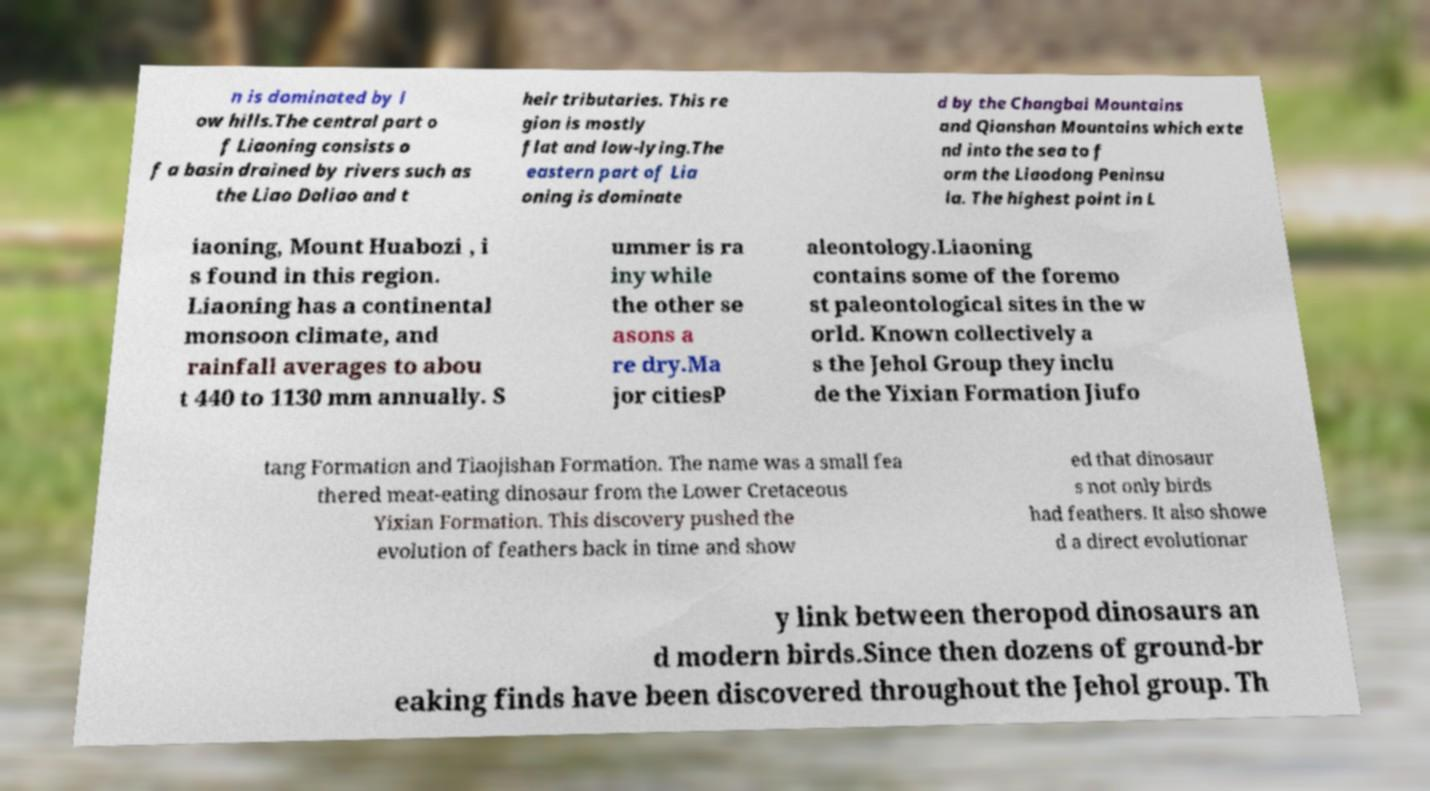Please read and relay the text visible in this image. What does it say? n is dominated by l ow hills.The central part o f Liaoning consists o f a basin drained by rivers such as the Liao Daliao and t heir tributaries. This re gion is mostly flat and low-lying.The eastern part of Lia oning is dominate d by the Changbai Mountains and Qianshan Mountains which exte nd into the sea to f orm the Liaodong Peninsu la. The highest point in L iaoning, Mount Huabozi , i s found in this region. Liaoning has a continental monsoon climate, and rainfall averages to abou t 440 to 1130 mm annually. S ummer is ra iny while the other se asons a re dry.Ma jor citiesP aleontology.Liaoning contains some of the foremo st paleontological sites in the w orld. Known collectively a s the Jehol Group they inclu de the Yixian Formation Jiufo tang Formation and Tiaojishan Formation. The name was a small fea thered meat-eating dinosaur from the Lower Cretaceous Yixian Formation. This discovery pushed the evolution of feathers back in time and show ed that dinosaur s not only birds had feathers. It also showe d a direct evolutionar y link between theropod dinosaurs an d modern birds.Since then dozens of ground-br eaking finds have been discovered throughout the Jehol group. Th 